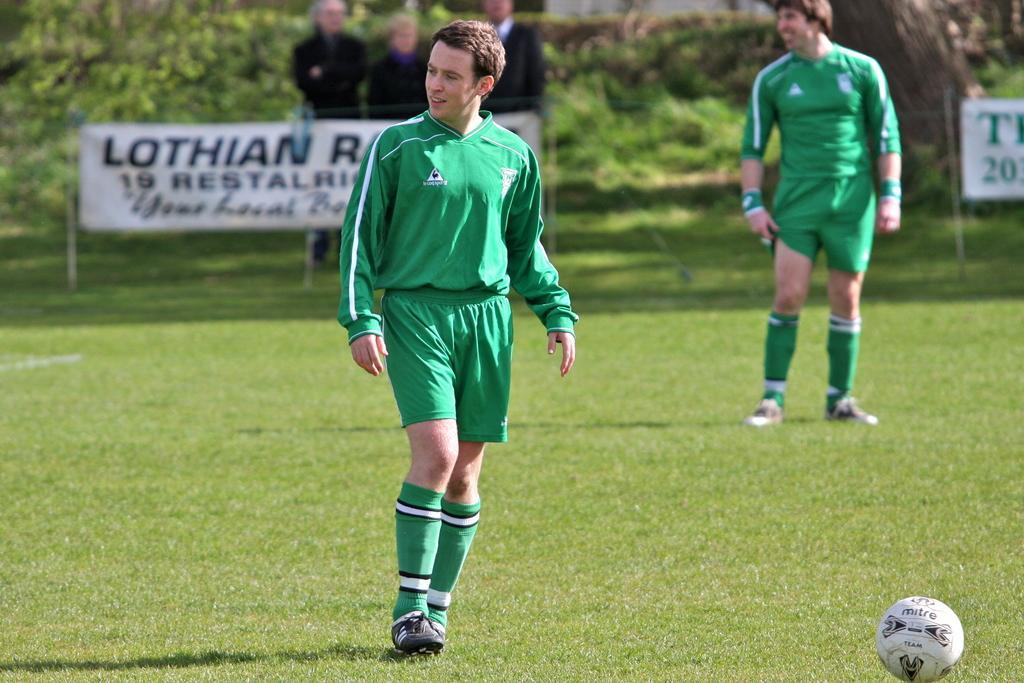Describe this image in one or two sentences. In this image there are two players on the playground and there is a ball, behind them there are spectators and banners. In the background there are trees. 